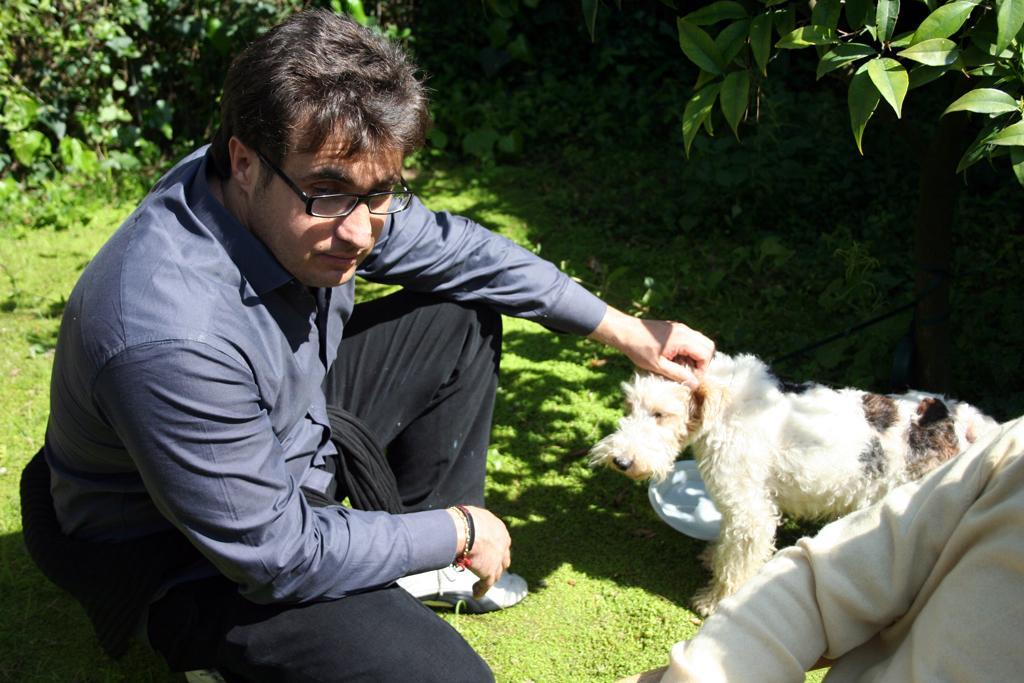How would you summarize this image in a sentence or two? The person wearing blue dress is sitting on his legs and placed his hand on a dog in front of him and there is another person in the right corner and the ground is greenery and there are trees around him. 